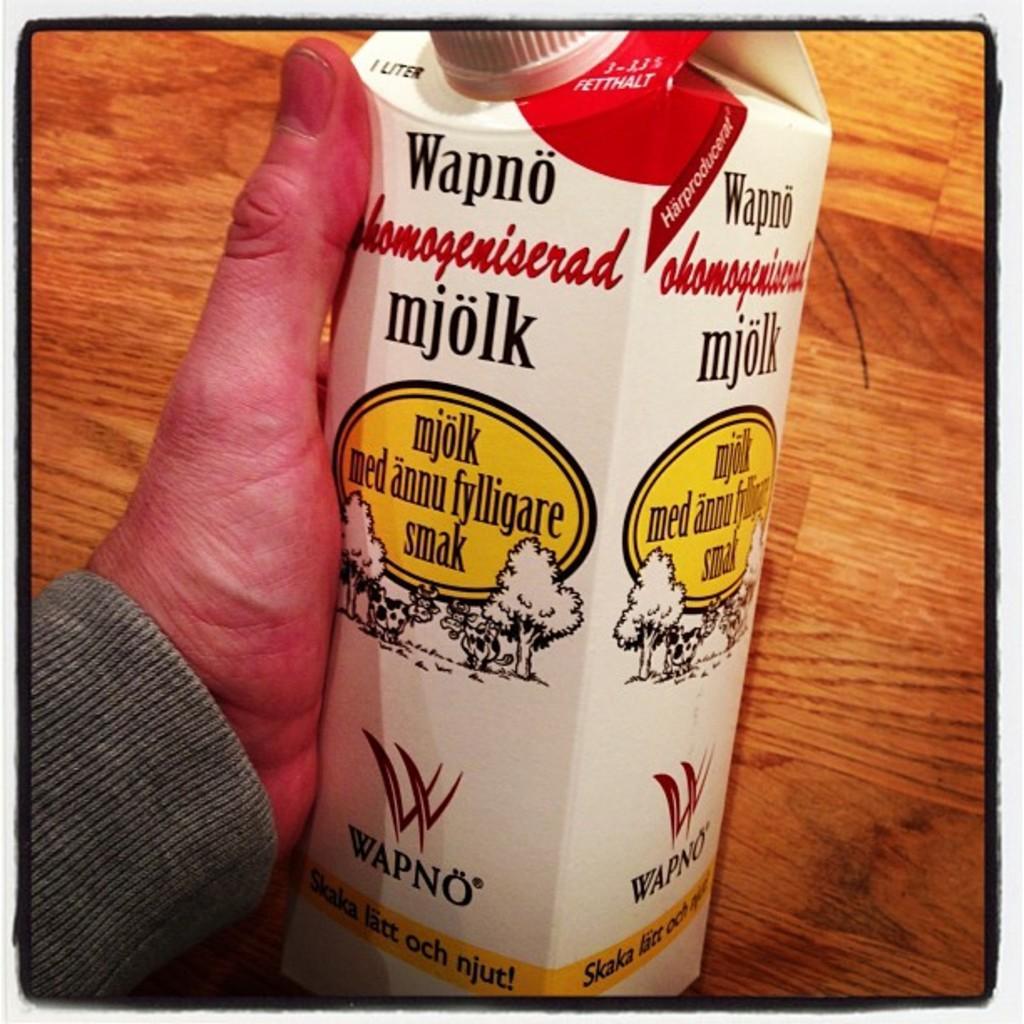Describe this image in one or two sentences. In this image we can see one person's hand holding an object with text and images. It looks like a table in the background. 